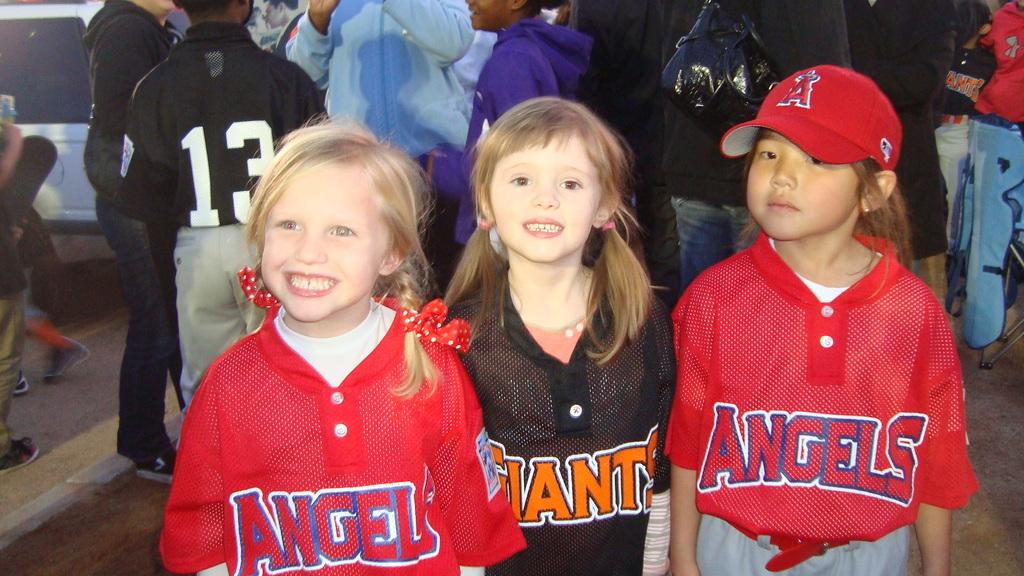What team do the girls on the left and right support?
Your answer should be very brief. Angels. What numbers are on the back of the black shirt?
Your answer should be very brief. 13. 